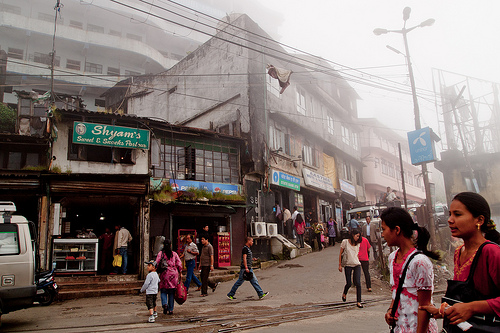<image>
Is there a lamp post behind the boy? No. The lamp post is not behind the boy. From this viewpoint, the lamp post appears to be positioned elsewhere in the scene. Is there a sign in front of the woman? No. The sign is not in front of the woman. The spatial positioning shows a different relationship between these objects. 